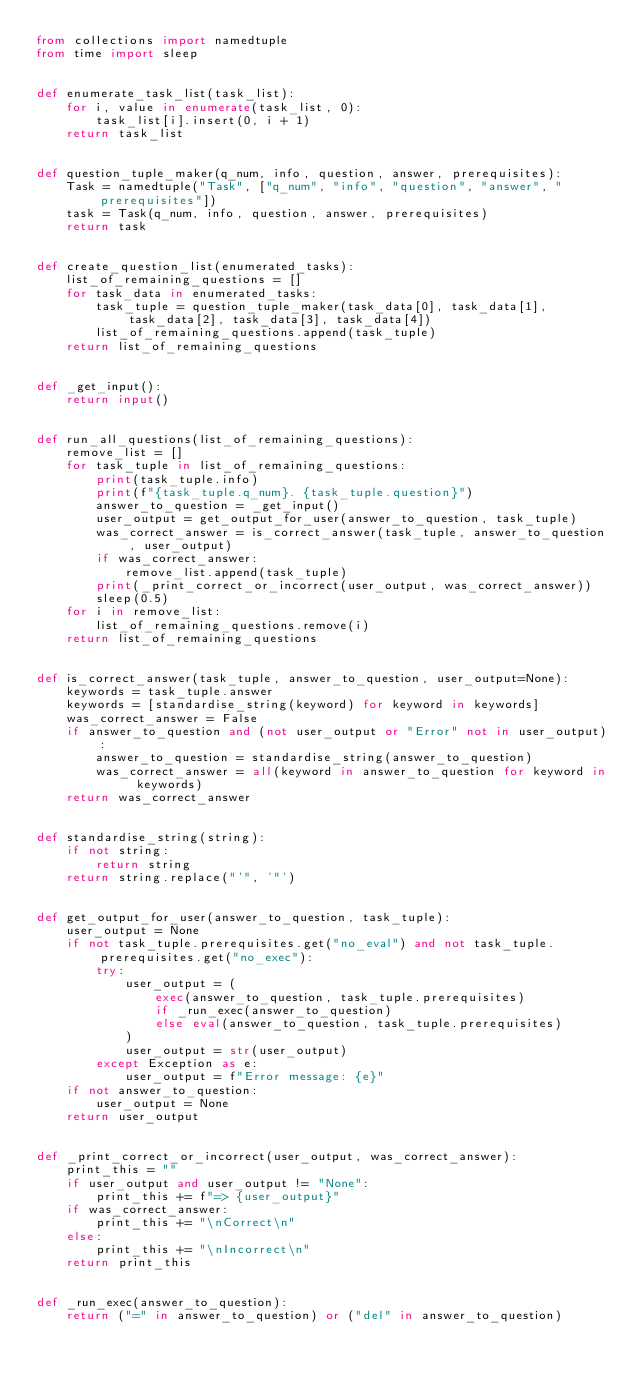Convert code to text. <code><loc_0><loc_0><loc_500><loc_500><_Python_>from collections import namedtuple
from time import sleep


def enumerate_task_list(task_list):
    for i, value in enumerate(task_list, 0):
        task_list[i].insert(0, i + 1)
    return task_list


def question_tuple_maker(q_num, info, question, answer, prerequisites):
    Task = namedtuple("Task", ["q_num", "info", "question", "answer", "prerequisites"])
    task = Task(q_num, info, question, answer, prerequisites)
    return task


def create_question_list(enumerated_tasks):
    list_of_remaining_questions = []
    for task_data in enumerated_tasks:
        task_tuple = question_tuple_maker(task_data[0], task_data[1], task_data[2], task_data[3], task_data[4])
        list_of_remaining_questions.append(task_tuple)
    return list_of_remaining_questions


def _get_input():
    return input()


def run_all_questions(list_of_remaining_questions):
    remove_list = []
    for task_tuple in list_of_remaining_questions:
        print(task_tuple.info)
        print(f"{task_tuple.q_num}. {task_tuple.question}")
        answer_to_question = _get_input()
        user_output = get_output_for_user(answer_to_question, task_tuple)
        was_correct_answer = is_correct_answer(task_tuple, answer_to_question, user_output)
        if was_correct_answer:
            remove_list.append(task_tuple)
        print(_print_correct_or_incorrect(user_output, was_correct_answer))
        sleep(0.5)
    for i in remove_list:
        list_of_remaining_questions.remove(i)
    return list_of_remaining_questions


def is_correct_answer(task_tuple, answer_to_question, user_output=None):
    keywords = task_tuple.answer
    keywords = [standardise_string(keyword) for keyword in keywords]
    was_correct_answer = False
    if answer_to_question and (not user_output or "Error" not in user_output):
        answer_to_question = standardise_string(answer_to_question)
        was_correct_answer = all(keyword in answer_to_question for keyword in keywords)
    return was_correct_answer


def standardise_string(string):
    if not string:
        return string
    return string.replace("'", '"')


def get_output_for_user(answer_to_question, task_tuple):
    user_output = None
    if not task_tuple.prerequisites.get("no_eval") and not task_tuple.prerequisites.get("no_exec"):
        try:
            user_output = (
                exec(answer_to_question, task_tuple.prerequisites)
                if _run_exec(answer_to_question)
                else eval(answer_to_question, task_tuple.prerequisites)
            )
            user_output = str(user_output)
        except Exception as e:
            user_output = f"Error message: {e}"
    if not answer_to_question:
        user_output = None
    return user_output


def _print_correct_or_incorrect(user_output, was_correct_answer):
    print_this = ""
    if user_output and user_output != "None":
        print_this += f"=> {user_output}"
    if was_correct_answer:
        print_this += "\nCorrect\n"
    else:
        print_this += "\nIncorrect\n"
    return print_this


def _run_exec(answer_to_question):
    return ("=" in answer_to_question) or ("del" in answer_to_question)
</code> 